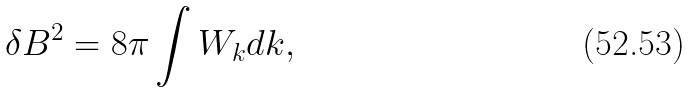Convert formula to latex. <formula><loc_0><loc_0><loc_500><loc_500>\delta B ^ { 2 } = 8 \pi \int W _ { k } d k ,</formula> 